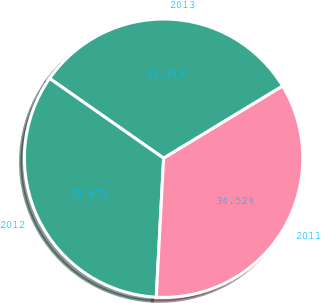<chart> <loc_0><loc_0><loc_500><loc_500><pie_chart><fcel>2013<fcel>2012<fcel>2011<nl><fcel>31.61%<fcel>33.87%<fcel>34.52%<nl></chart> 